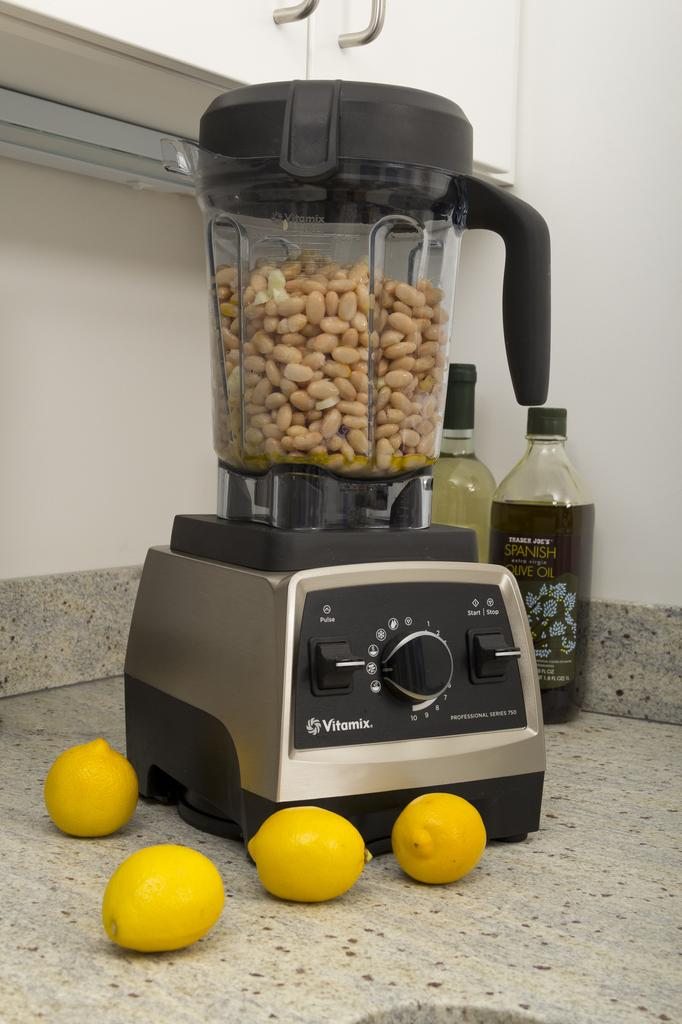<image>
Create a compact narrative representing the image presented. a Vitamix blender full of peanuts on a counter with Spanish Oil 